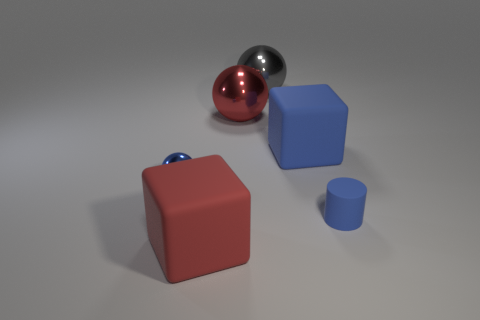Are there an equal number of matte cylinders behind the large gray thing and small shiny things left of the tiny blue ball?
Offer a very short reply. Yes. How many gray objects are the same material as the big red cube?
Offer a terse response. 0. What shape is the rubber thing that is the same color as the cylinder?
Make the answer very short. Cube. There is a shiny sphere that is left of the large red thing behind the large blue matte thing; what is its size?
Offer a terse response. Small. Is the shape of the small thing right of the red block the same as the blue rubber thing behind the tiny matte object?
Provide a succinct answer. No. Is the number of metallic balls that are on the right side of the big blue matte cube the same as the number of blue cubes?
Provide a short and direct response. No. What is the color of the other big metallic thing that is the same shape as the large red shiny thing?
Keep it short and to the point. Gray. Is the large red thing that is in front of the rubber cylinder made of the same material as the tiny blue cylinder?
Offer a terse response. Yes. How many big objects are rubber objects or blue matte cylinders?
Make the answer very short. 2. What size is the red rubber block?
Keep it short and to the point. Large. 